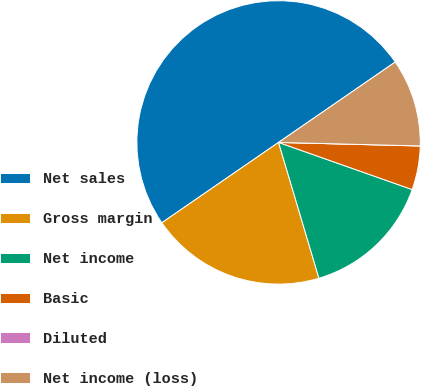Convert chart to OTSL. <chart><loc_0><loc_0><loc_500><loc_500><pie_chart><fcel>Net sales<fcel>Gross margin<fcel>Net income<fcel>Basic<fcel>Diluted<fcel>Net income (loss)<nl><fcel>49.99%<fcel>20.0%<fcel>15.0%<fcel>5.0%<fcel>0.0%<fcel>10.0%<nl></chart> 